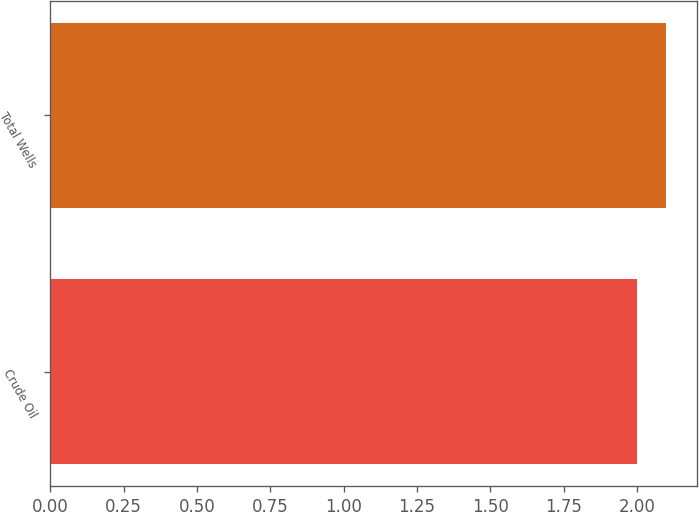<chart> <loc_0><loc_0><loc_500><loc_500><bar_chart><fcel>Crude Oil<fcel>Total Wells<nl><fcel>2<fcel>2.1<nl></chart> 